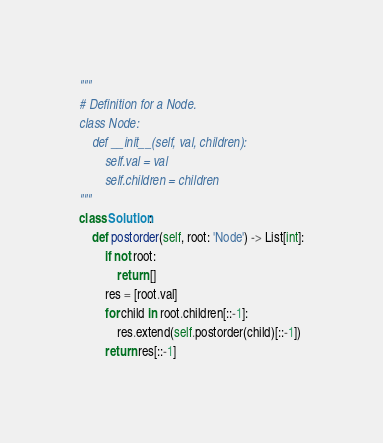<code> <loc_0><loc_0><loc_500><loc_500><_Python_>"""
# Definition for a Node.
class Node:
    def __init__(self, val, children):
        self.val = val
        self.children = children
"""
class Solution:
    def postorder(self, root: 'Node') -> List[int]:
        if not root:
            return []
        res = [root.val]
        for child in root.children[::-1]:
            res.extend(self.postorder(child)[::-1])
        return res[::-1]</code> 